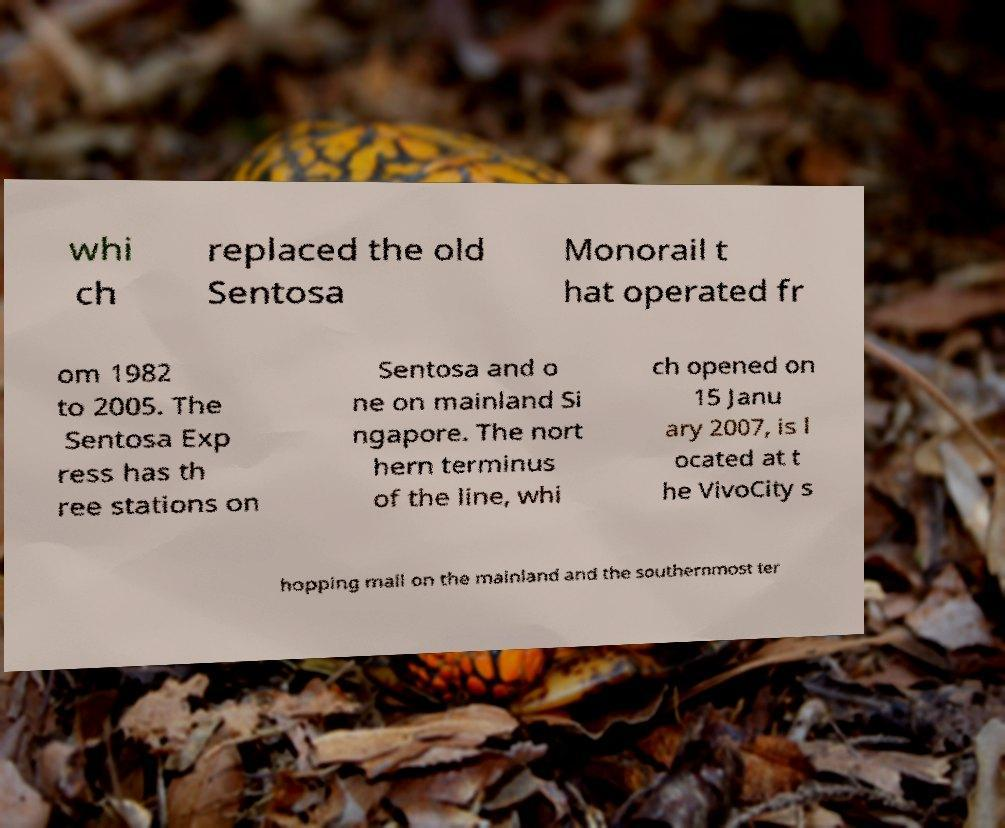Please read and relay the text visible in this image. What does it say? whi ch replaced the old Sentosa Monorail t hat operated fr om 1982 to 2005. The Sentosa Exp ress has th ree stations on Sentosa and o ne on mainland Si ngapore. The nort hern terminus of the line, whi ch opened on 15 Janu ary 2007, is l ocated at t he VivoCity s hopping mall on the mainland and the southernmost ter 